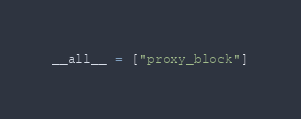<code> <loc_0><loc_0><loc_500><loc_500><_Python_>__all__ = ["proxy_block"]
</code> 